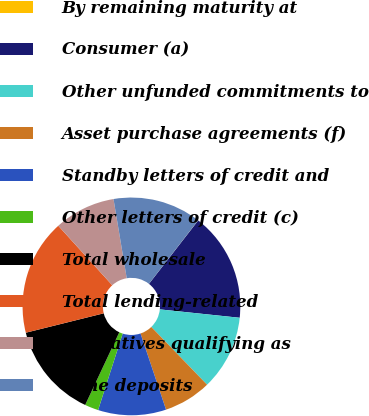Convert chart. <chart><loc_0><loc_0><loc_500><loc_500><pie_chart><fcel>By remaining maturity at<fcel>Consumer (a)<fcel>Other unfunded commitments to<fcel>Asset purchase agreements (f)<fcel>Standby letters of credit and<fcel>Other letters of credit (c)<fcel>Total wholesale<fcel>Total lending-related<fcel>Derivatives qualifying as<fcel>Time deposits<nl><fcel>0.02%<fcel>16.15%<fcel>11.11%<fcel>7.08%<fcel>10.1%<fcel>2.03%<fcel>14.13%<fcel>17.16%<fcel>9.09%<fcel>13.13%<nl></chart> 